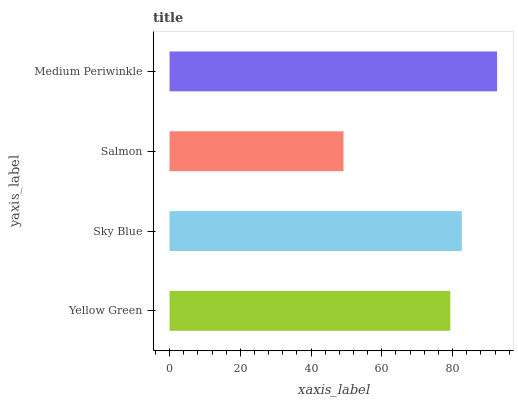Is Salmon the minimum?
Answer yes or no. Yes. Is Medium Periwinkle the maximum?
Answer yes or no. Yes. Is Sky Blue the minimum?
Answer yes or no. No. Is Sky Blue the maximum?
Answer yes or no. No. Is Sky Blue greater than Yellow Green?
Answer yes or no. Yes. Is Yellow Green less than Sky Blue?
Answer yes or no. Yes. Is Yellow Green greater than Sky Blue?
Answer yes or no. No. Is Sky Blue less than Yellow Green?
Answer yes or no. No. Is Sky Blue the high median?
Answer yes or no. Yes. Is Yellow Green the low median?
Answer yes or no. Yes. Is Salmon the high median?
Answer yes or no. No. Is Salmon the low median?
Answer yes or no. No. 